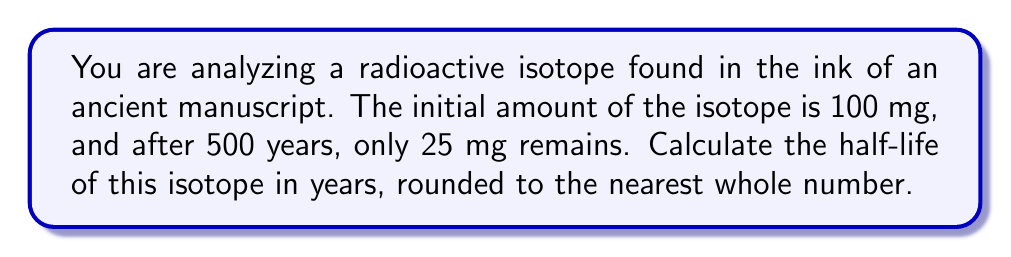Could you help me with this problem? To solve this problem, we'll use the exponential decay formula and the concept of half-life:

1) The exponential decay formula is:
   $A(t) = A_0 \cdot e^{-\lambda t}$
   Where:
   $A(t)$ is the amount remaining after time $t$
   $A_0$ is the initial amount
   $\lambda$ is the decay constant
   $t$ is the time elapsed

2) We know:
   $A_0 = 100$ mg
   $A(500) = 25$ mg
   $t = 500$ years

3) Substituting these values into the formula:
   $25 = 100 \cdot e^{-500\lambda}$

4) Simplifying:
   $\frac{1}{4} = e^{-500\lambda}$

5) Taking the natural log of both sides:
   $\ln(\frac{1}{4}) = -500\lambda$

6) Solving for $\lambda$:
   $\lambda = \frac{\ln(4)}{500} \approx 0.002773$ year$^{-1}$

7) The half-life formula is:
   $t_{1/2} = \frac{\ln(2)}{\lambda}$

8) Substituting our $\lambda$ value:
   $t_{1/2} = \frac{\ln(2)}{0.002773} \approx 250$ years

9) Rounding to the nearest whole number:
   $t_{1/2} = 250$ years
Answer: 250 years 